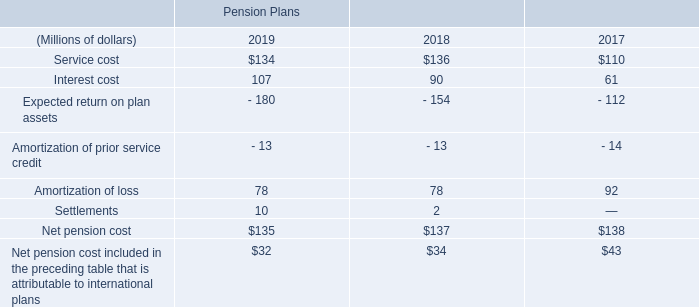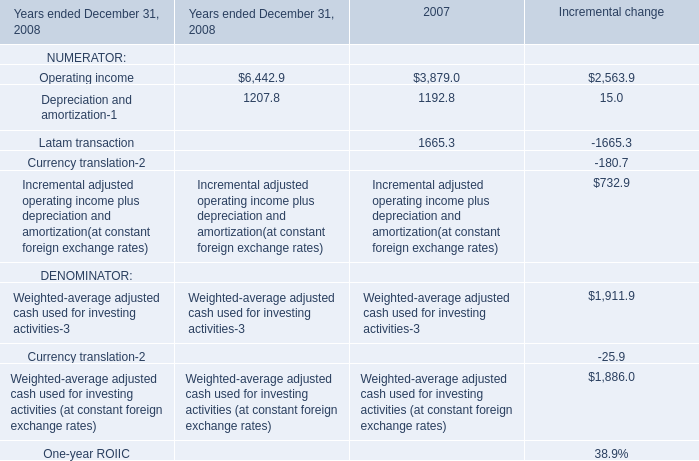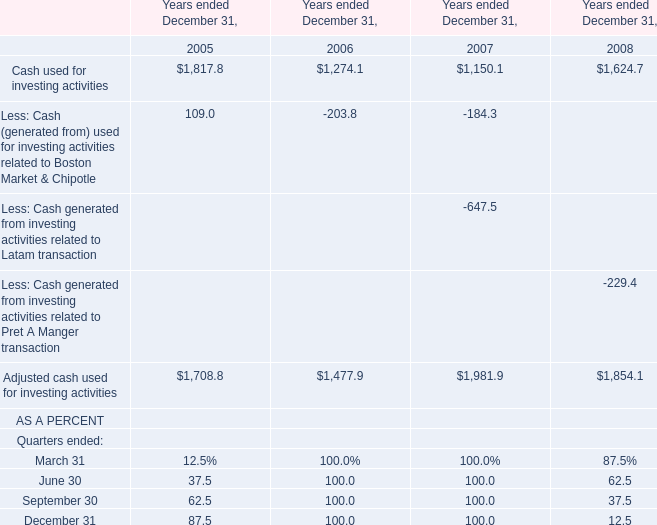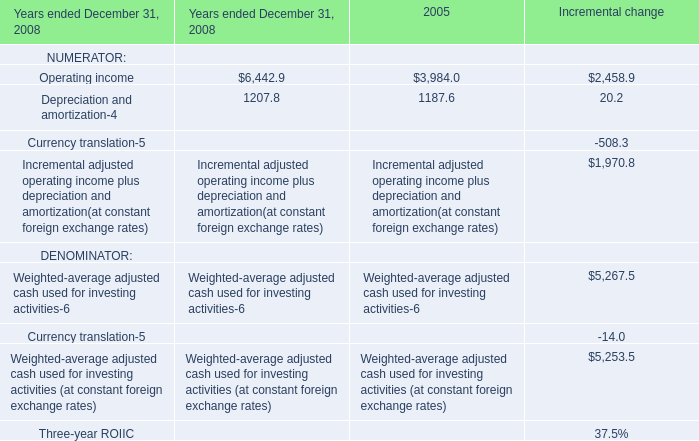What's the total amount of the Adjusted cash used for investing activities in the years where Cash used for investing activities greater than 0? 
Computations: (((1708.8 + 1477.9) + 1981.9) + 1854.1)
Answer: 7022.7. 